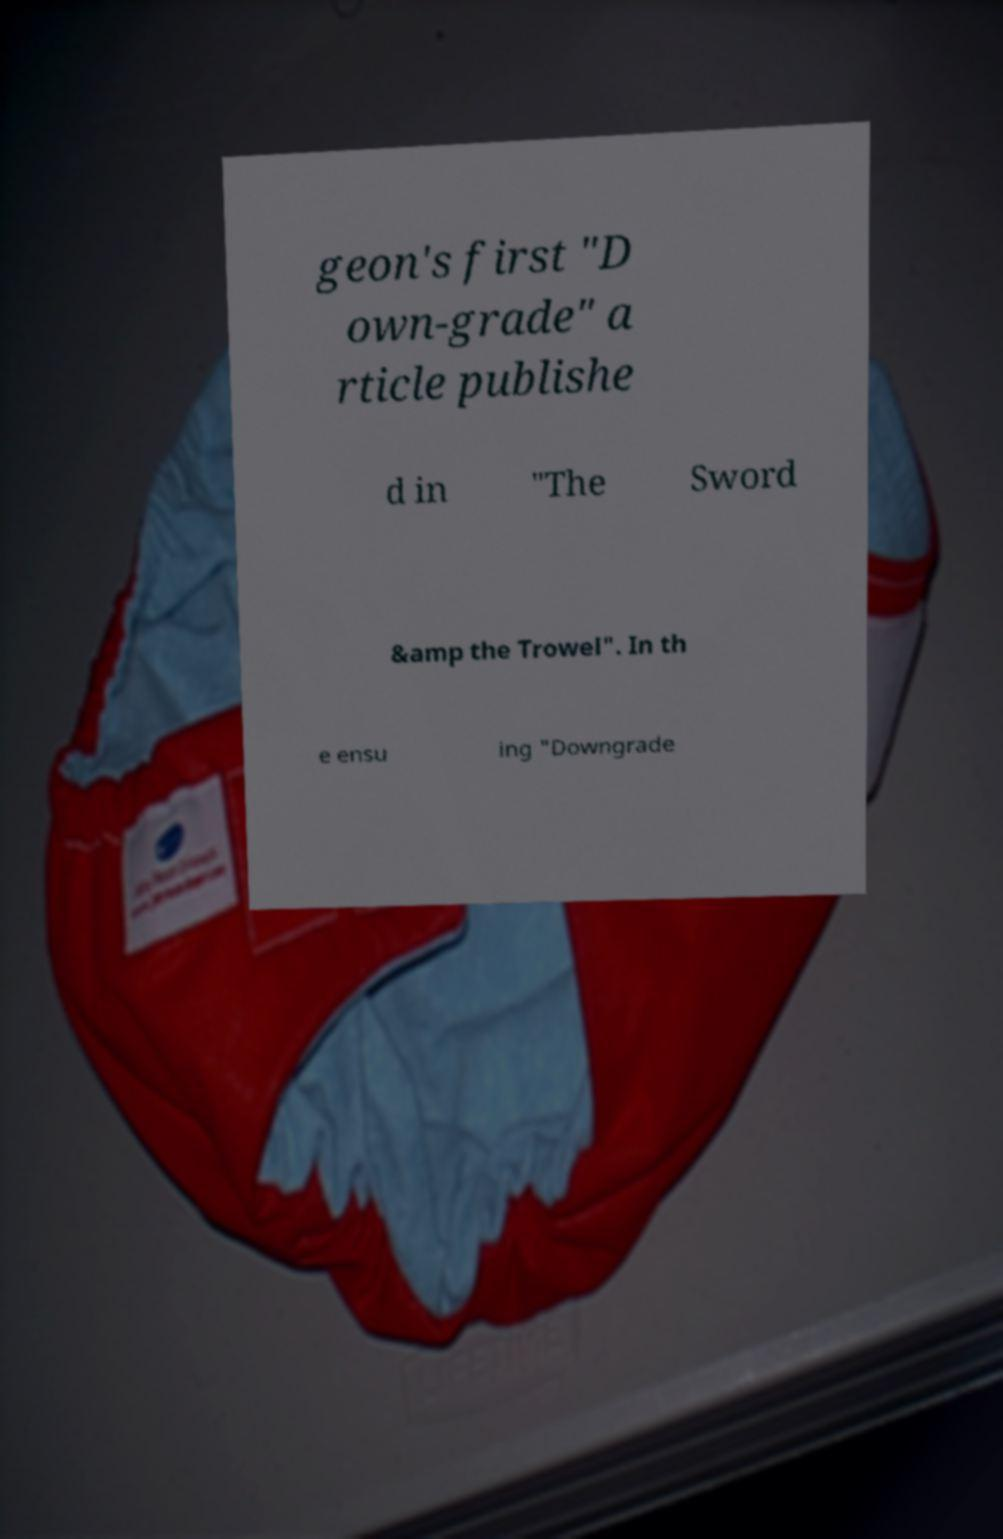Please read and relay the text visible in this image. What does it say? geon's first "D own-grade" a rticle publishe d in "The Sword &amp the Trowel". In th e ensu ing "Downgrade 